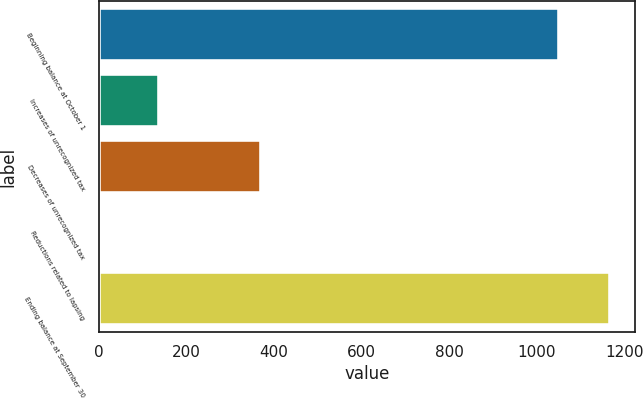Convert chart. <chart><loc_0><loc_0><loc_500><loc_500><bar_chart><fcel>Beginning balance at October 1<fcel>Increases of unrecognized tax<fcel>Decreases of unrecognized tax<fcel>Reductions related to lapsing<fcel>Ending balance at September 30<nl><fcel>1051<fcel>138<fcel>369.6<fcel>2<fcel>1166.8<nl></chart> 